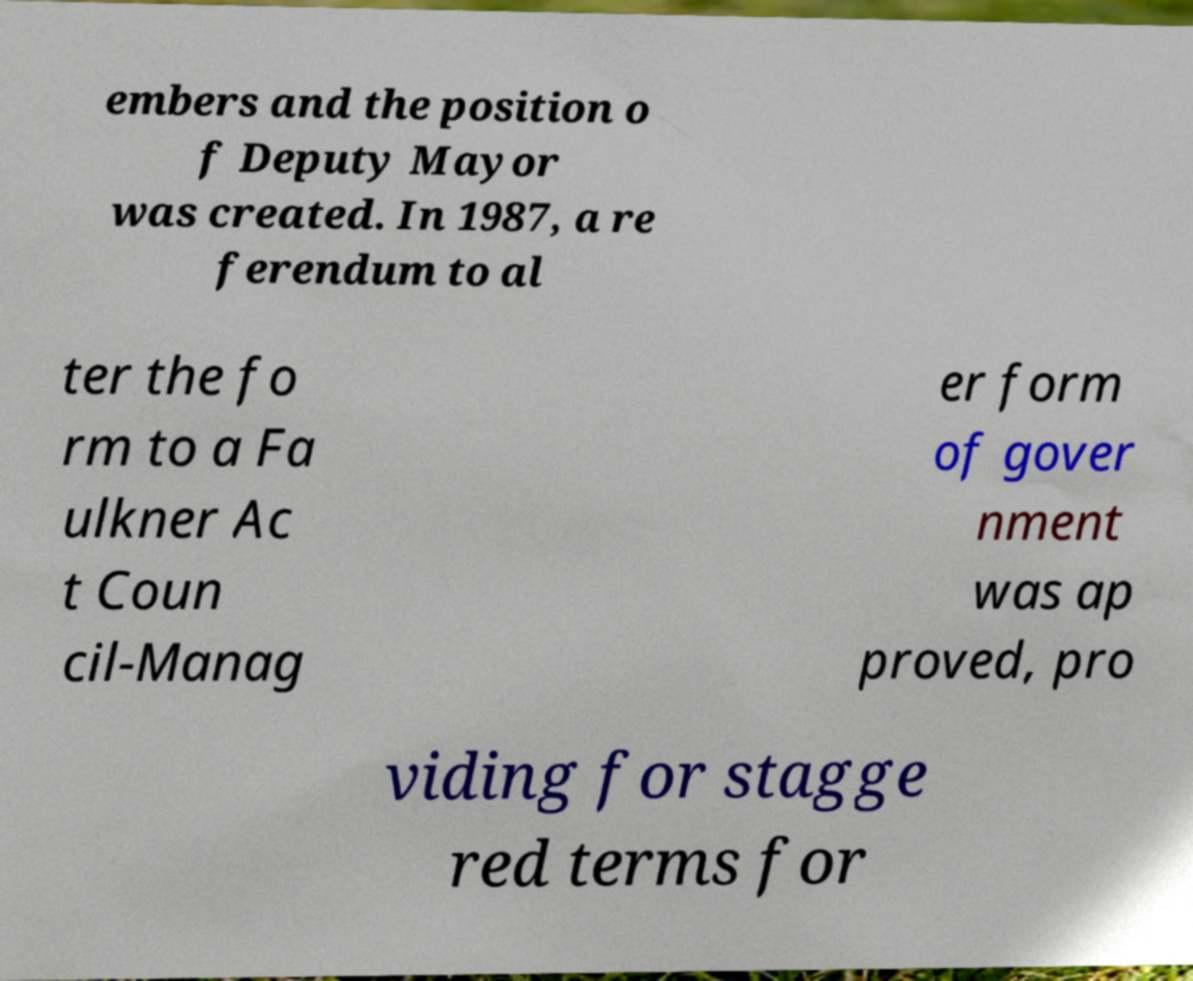I need the written content from this picture converted into text. Can you do that? embers and the position o f Deputy Mayor was created. In 1987, a re ferendum to al ter the fo rm to a Fa ulkner Ac t Coun cil-Manag er form of gover nment was ap proved, pro viding for stagge red terms for 